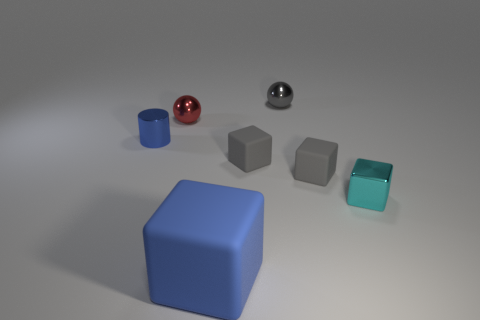There is a block that is the same color as the small metal cylinder; what size is it?
Your answer should be compact. Large. Is there any other thing that is the same size as the red metallic object?
Your response must be concise. Yes. What material is the gray thing that is to the left of the sphere right of the small red object?
Provide a short and direct response. Rubber. How many metal objects are either big blue objects or cyan things?
Give a very brief answer. 1. What is the color of the small metal thing that is the same shape as the big thing?
Ensure brevity in your answer.  Cyan. How many small rubber blocks have the same color as the big cube?
Offer a terse response. 0. Is there a small cyan metallic object on the right side of the metallic ball on the left side of the large blue rubber object?
Offer a very short reply. Yes. What number of tiny things are both in front of the red metal sphere and on the left side of the large blue block?
Offer a very short reply. 1. How many tiny balls have the same material as the small red thing?
Your answer should be very brief. 1. There is a blue object in front of the blue object behind the cyan thing; how big is it?
Offer a very short reply. Large. 